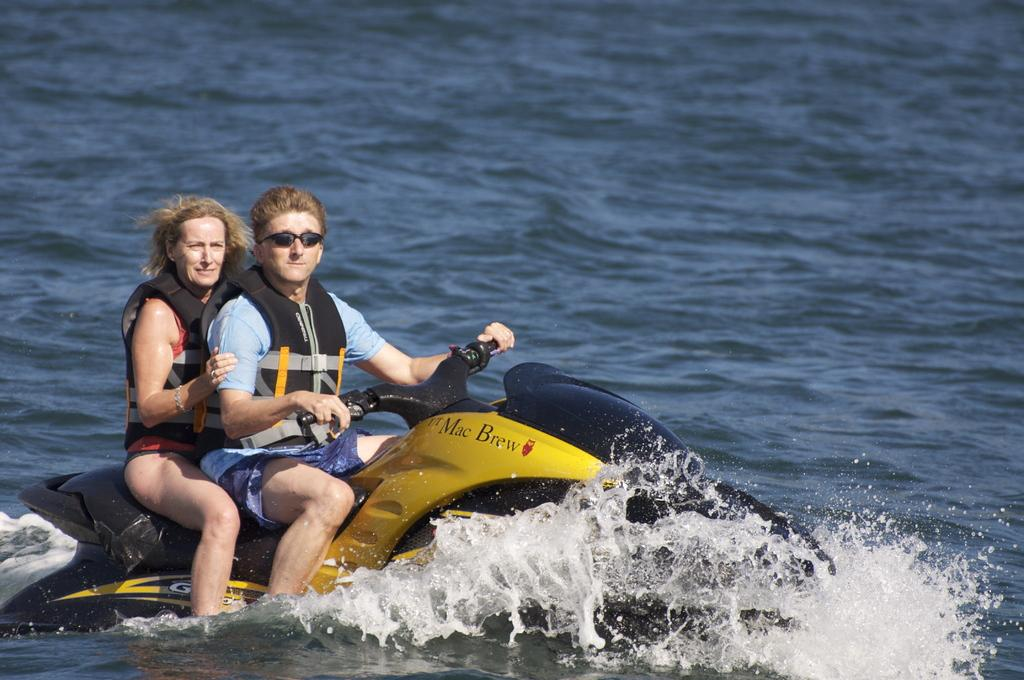<image>
Describe the image concisely. Couple riding on a jetski that is branded Mac Brew. 